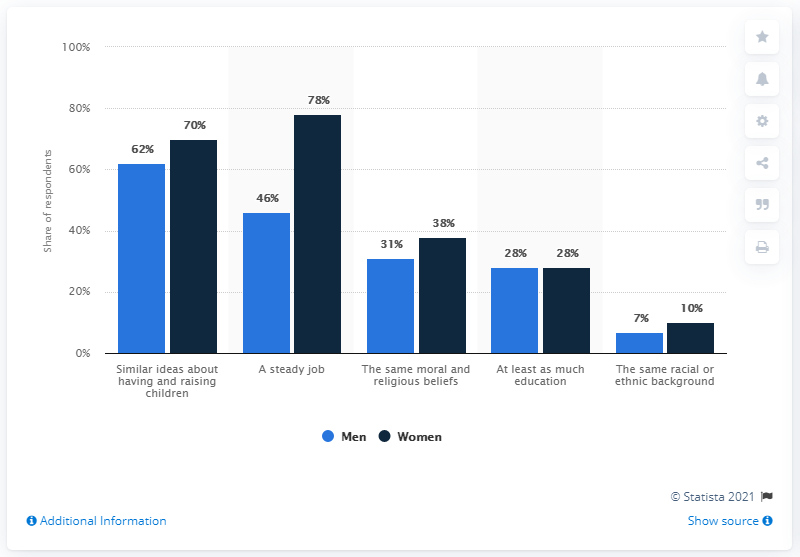Highlight a few significant elements in this photo. The leftmost bar represents 62% of the total. The difference between the highest dark blue bar and the lowest light blue bar is 71. 